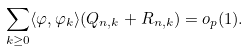Convert formula to latex. <formula><loc_0><loc_0><loc_500><loc_500>\sum _ { k \geq 0 } \langle \varphi , \varphi _ { k } \rangle ( Q _ { n , k } + R _ { n , k } ) = o _ { p } ( 1 ) .</formula> 